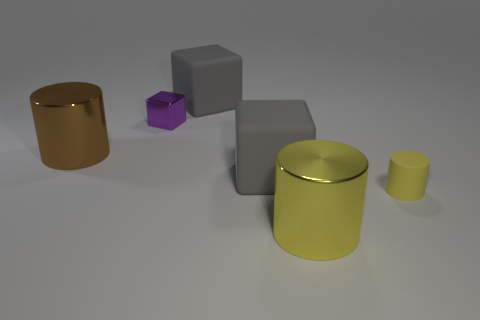Can you tell me what the materials of the objects might be? The objects in the image seem to have smooth surfaces with metallic and matte finishes, suggesting they could be made of materials like metal for the shiny cylinders and plastic or painted wood for the cubes. 